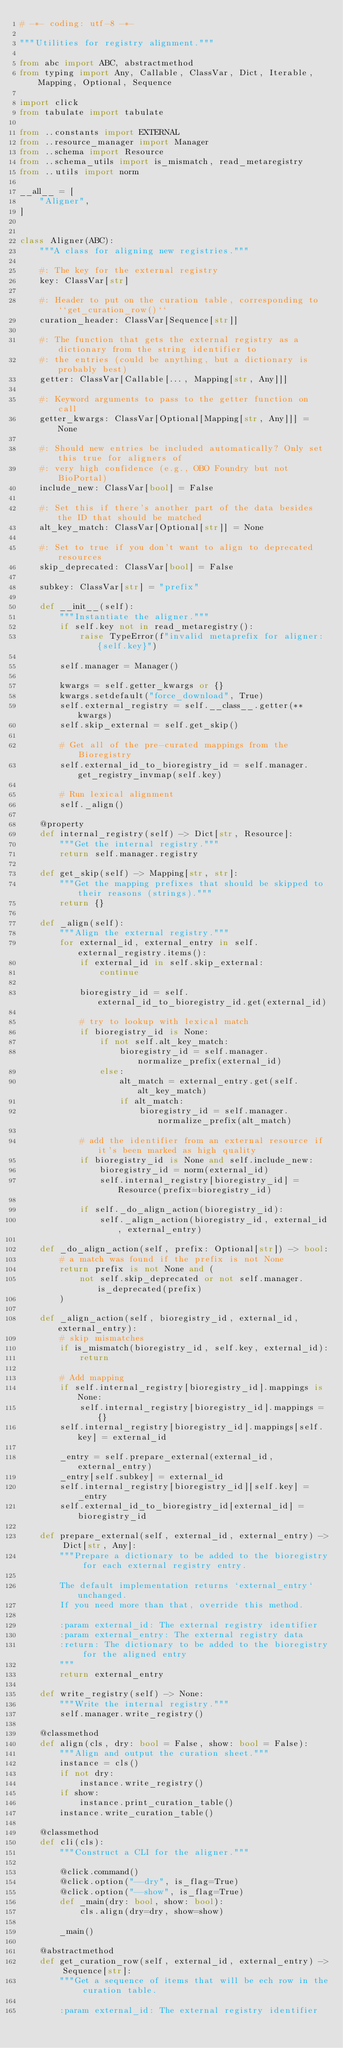<code> <loc_0><loc_0><loc_500><loc_500><_Python_># -*- coding: utf-8 -*-

"""Utilities for registry alignment."""

from abc import ABC, abstractmethod
from typing import Any, Callable, ClassVar, Dict, Iterable, Mapping, Optional, Sequence

import click
from tabulate import tabulate

from ..constants import EXTERNAL
from ..resource_manager import Manager
from ..schema import Resource
from ..schema_utils import is_mismatch, read_metaregistry
from ..utils import norm

__all__ = [
    "Aligner",
]


class Aligner(ABC):
    """A class for aligning new registries."""

    #: The key for the external registry
    key: ClassVar[str]

    #: Header to put on the curation table, corresponding to ``get_curation_row()``
    curation_header: ClassVar[Sequence[str]]

    #: The function that gets the external registry as a dictionary from the string identifier to
    #: the entries (could be anything, but a dictionary is probably best)
    getter: ClassVar[Callable[..., Mapping[str, Any]]]

    #: Keyword arguments to pass to the getter function on call
    getter_kwargs: ClassVar[Optional[Mapping[str, Any]]] = None

    #: Should new entries be included automatically? Only set this true for aligners of
    #: very high confidence (e.g., OBO Foundry but not BioPortal)
    include_new: ClassVar[bool] = False

    #: Set this if there's another part of the data besides the ID that should be matched
    alt_key_match: ClassVar[Optional[str]] = None

    #: Set to true if you don't want to align to deprecated resources
    skip_deprecated: ClassVar[bool] = False

    subkey: ClassVar[str] = "prefix"

    def __init__(self):
        """Instantiate the aligner."""
        if self.key not in read_metaregistry():
            raise TypeError(f"invalid metaprefix for aligner: {self.key}")

        self.manager = Manager()

        kwargs = self.getter_kwargs or {}
        kwargs.setdefault("force_download", True)
        self.external_registry = self.__class__.getter(**kwargs)
        self.skip_external = self.get_skip()

        # Get all of the pre-curated mappings from the Bioregistry
        self.external_id_to_bioregistry_id = self.manager.get_registry_invmap(self.key)

        # Run lexical alignment
        self._align()

    @property
    def internal_registry(self) -> Dict[str, Resource]:
        """Get the internal registry."""
        return self.manager.registry

    def get_skip(self) -> Mapping[str, str]:
        """Get the mapping prefixes that should be skipped to their reasons (strings)."""
        return {}

    def _align(self):
        """Align the external registry."""
        for external_id, external_entry in self.external_registry.items():
            if external_id in self.skip_external:
                continue

            bioregistry_id = self.external_id_to_bioregistry_id.get(external_id)

            # try to lookup with lexical match
            if bioregistry_id is None:
                if not self.alt_key_match:
                    bioregistry_id = self.manager.normalize_prefix(external_id)
                else:
                    alt_match = external_entry.get(self.alt_key_match)
                    if alt_match:
                        bioregistry_id = self.manager.normalize_prefix(alt_match)

            # add the identifier from an external resource if it's been marked as high quality
            if bioregistry_id is None and self.include_new:
                bioregistry_id = norm(external_id)
                self.internal_registry[bioregistry_id] = Resource(prefix=bioregistry_id)

            if self._do_align_action(bioregistry_id):
                self._align_action(bioregistry_id, external_id, external_entry)

    def _do_align_action(self, prefix: Optional[str]) -> bool:
        # a match was found if the prefix is not None
        return prefix is not None and (
            not self.skip_deprecated or not self.manager.is_deprecated(prefix)
        )

    def _align_action(self, bioregistry_id, external_id, external_entry):
        # skip mismatches
        if is_mismatch(bioregistry_id, self.key, external_id):
            return

        # Add mapping
        if self.internal_registry[bioregistry_id].mappings is None:
            self.internal_registry[bioregistry_id].mappings = {}
        self.internal_registry[bioregistry_id].mappings[self.key] = external_id

        _entry = self.prepare_external(external_id, external_entry)
        _entry[self.subkey] = external_id
        self.internal_registry[bioregistry_id][self.key] = _entry
        self.external_id_to_bioregistry_id[external_id] = bioregistry_id

    def prepare_external(self, external_id, external_entry) -> Dict[str, Any]:
        """Prepare a dictionary to be added to the bioregistry for each external registry entry.

        The default implementation returns `external_entry` unchanged.
        If you need more than that, override this method.

        :param external_id: The external registry identifier
        :param external_entry: The external registry data
        :return: The dictionary to be added to the bioregistry for the aligned entry
        """
        return external_entry

    def write_registry(self) -> None:
        """Write the internal registry."""
        self.manager.write_registry()

    @classmethod
    def align(cls, dry: bool = False, show: bool = False):
        """Align and output the curation sheet."""
        instance = cls()
        if not dry:
            instance.write_registry()
        if show:
            instance.print_curation_table()
        instance.write_curation_table()

    @classmethod
    def cli(cls):
        """Construct a CLI for the aligner."""

        @click.command()
        @click.option("--dry", is_flag=True)
        @click.option("--show", is_flag=True)
        def _main(dry: bool, show: bool):
            cls.align(dry=dry, show=show)

        _main()

    @abstractmethod
    def get_curation_row(self, external_id, external_entry) -> Sequence[str]:
        """Get a sequence of items that will be ech row in the curation table.

        :param external_id: The external registry identifier</code> 